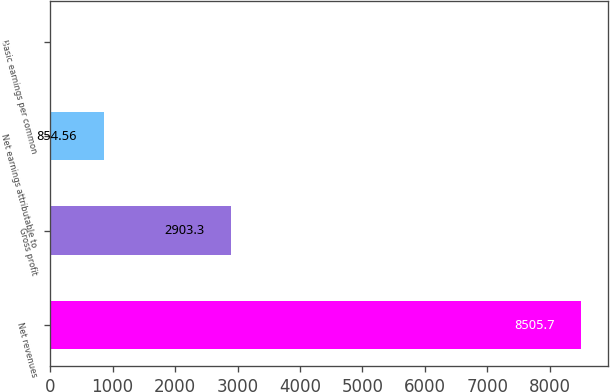Convert chart. <chart><loc_0><loc_0><loc_500><loc_500><bar_chart><fcel>Net revenues<fcel>Gross profit<fcel>Net earnings attributable to<fcel>Basic earnings per common<nl><fcel>8505.7<fcel>2903.3<fcel>854.56<fcel>4.43<nl></chart> 